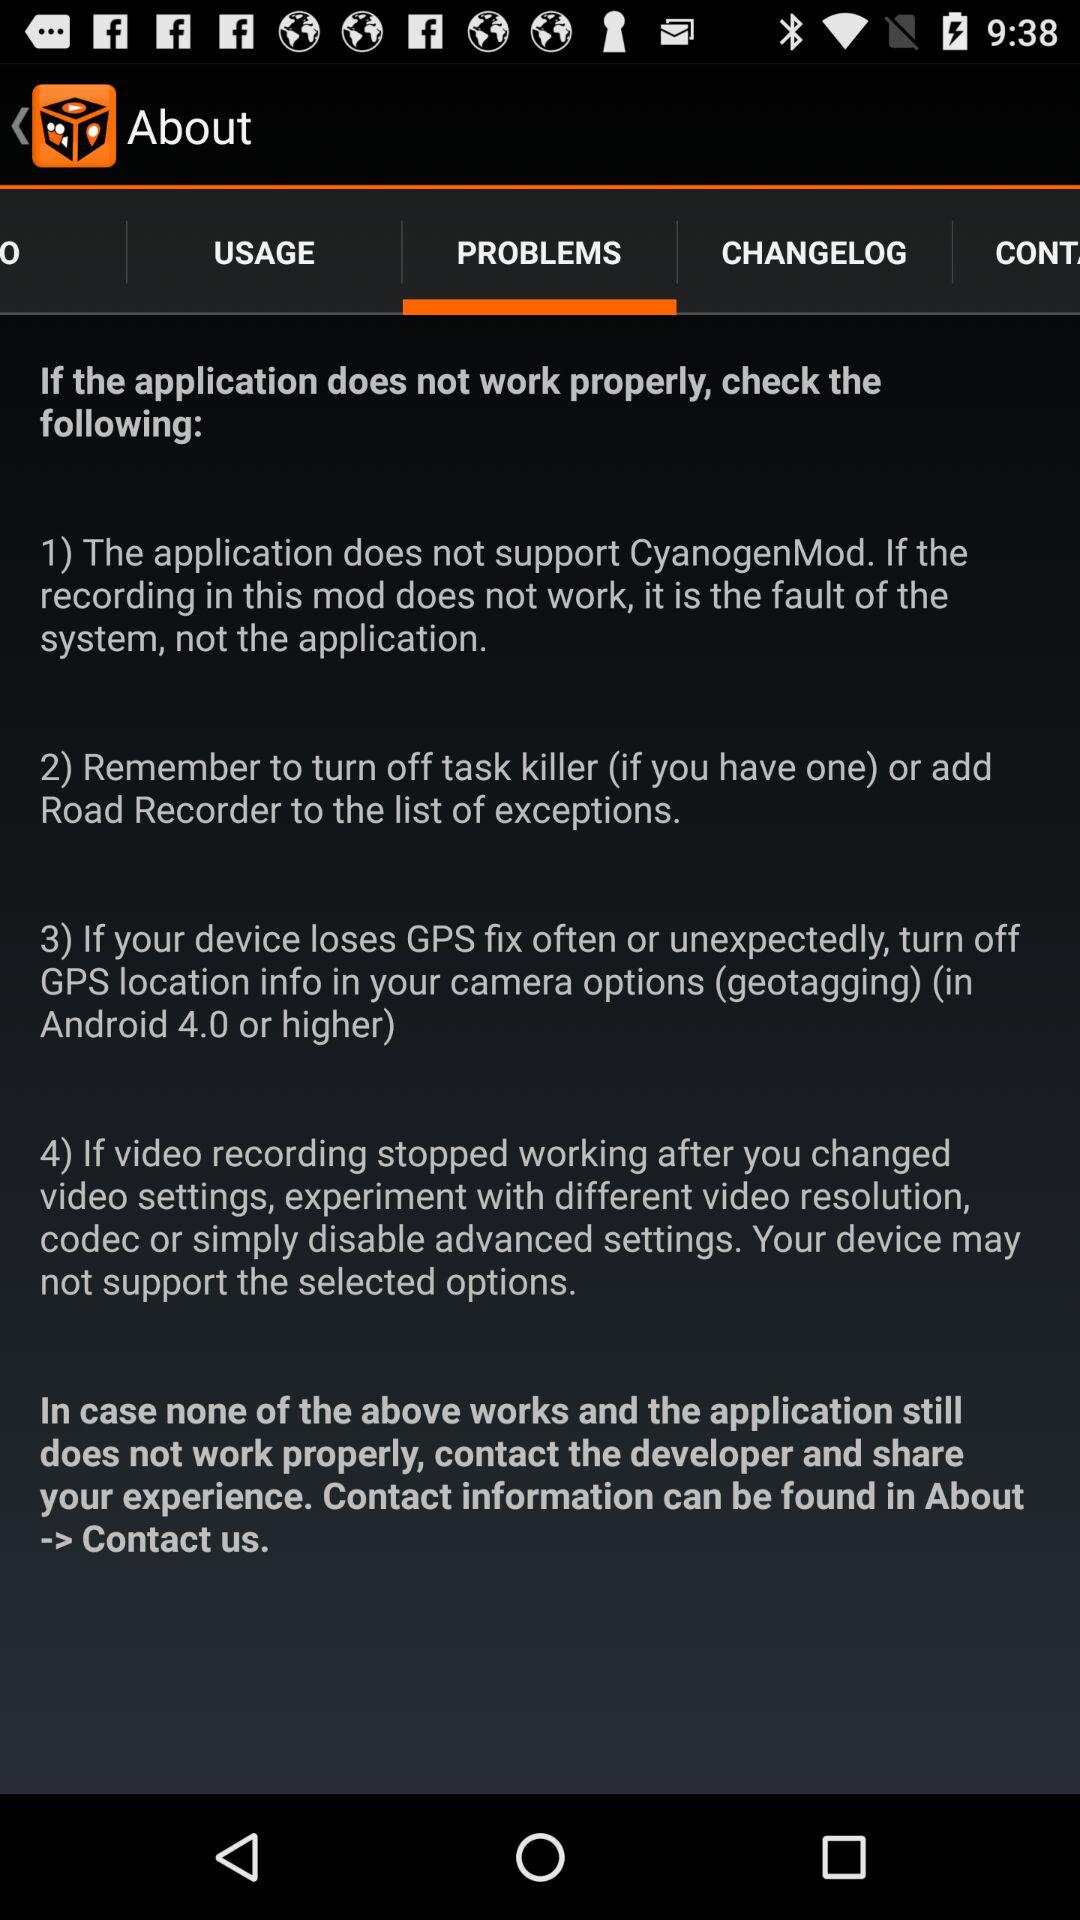Which tab is selected? The selected tab is "PROBLEMS". 